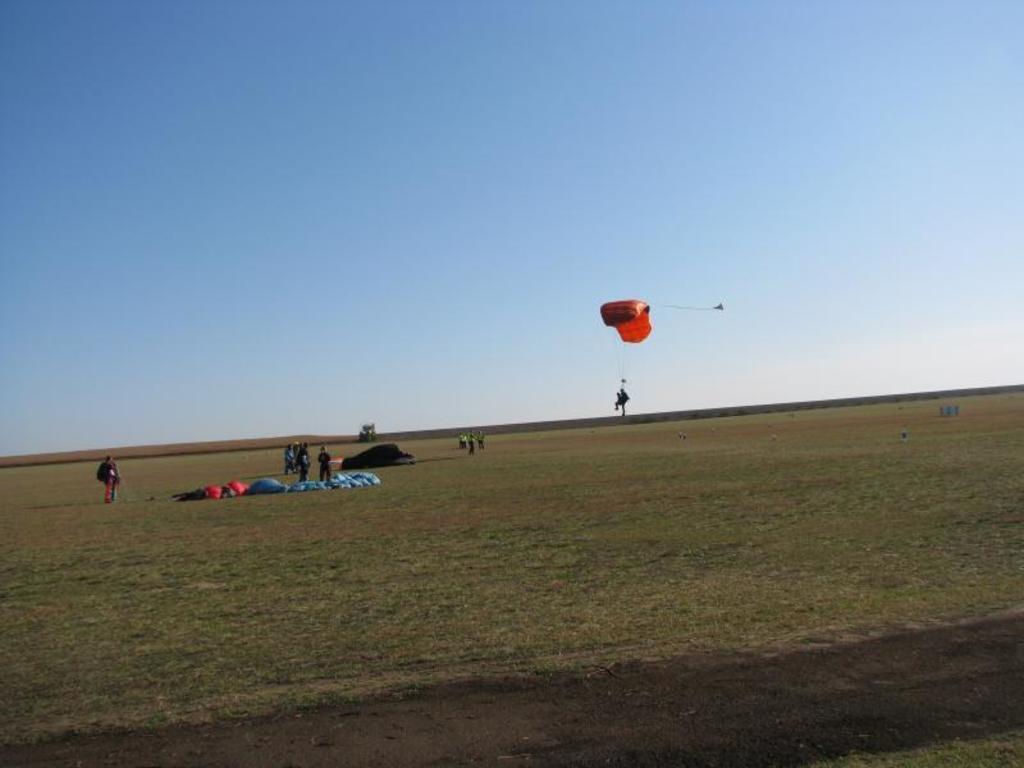Could you give a brief overview of what you see in this image? In this image I can see an open land. There are few persons standing. I can see a parachute. In the background I can see the sky. 